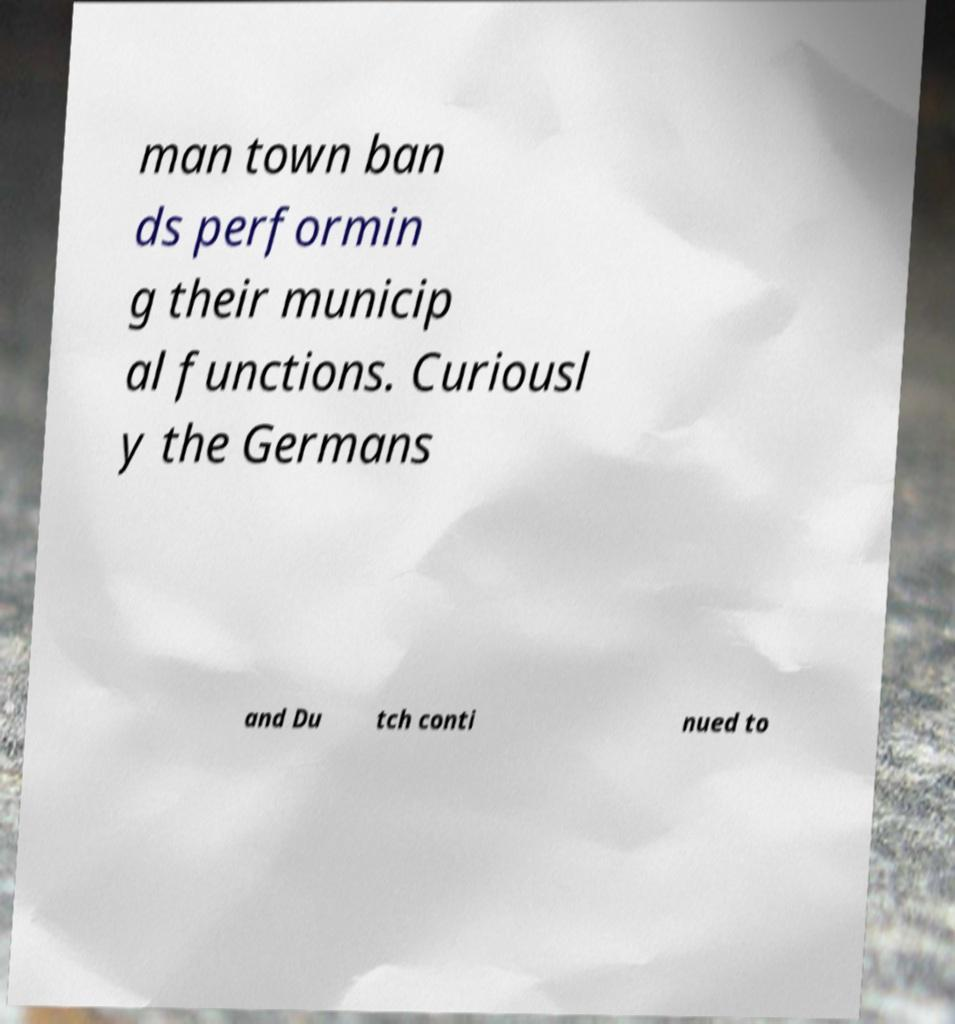What messages or text are displayed in this image? I need them in a readable, typed format. man town ban ds performin g their municip al functions. Curiousl y the Germans and Du tch conti nued to 